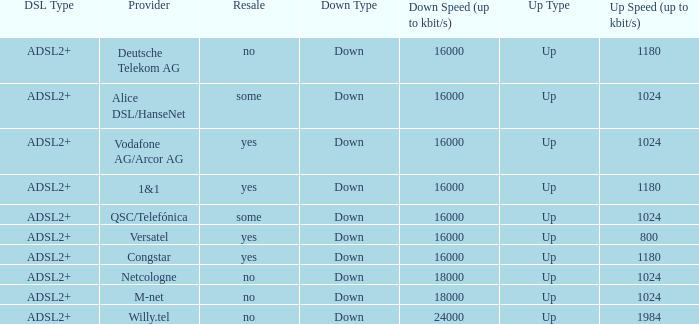Help me parse the entirety of this table. {'header': ['DSL Type', 'Provider', 'Resale', 'Down Type', 'Down Speed (up to kbit/s)', 'Up Type', 'Up Speed (up to kbit/s)'], 'rows': [['ADSL2+', 'Deutsche Telekom AG', 'no', 'Down', '16000', 'Up', '1180'], ['ADSL2+', 'Alice DSL/HanseNet', 'some', 'Down', '16000', 'Up', '1024'], ['ADSL2+', 'Vodafone AG/Arcor AG', 'yes', 'Down', '16000', 'Up', '1024'], ['ADSL2+', '1&1', 'yes', 'Down', '16000', 'Up', '1180'], ['ADSL2+', 'QSC/Telefónica', 'some', 'Down', '16000', 'Up', '1024'], ['ADSL2+', 'Versatel', 'yes', 'Down', '16000', 'Up', '800'], ['ADSL2+', 'Congstar', 'yes', 'Down', '16000', 'Up', '1180'], ['ADSL2+', 'Netcologne', 'no', 'Down', '18000', 'Up', '1024'], ['ADSL2+', 'M-net', 'no', 'Down', '18000', 'Up', '1024'], ['ADSL2+', 'Willy.tel', 'no', 'Down', '24000', 'Up', '1984']]} What is download bandwith where the provider is deutsche telekom ag? 16000.0. 